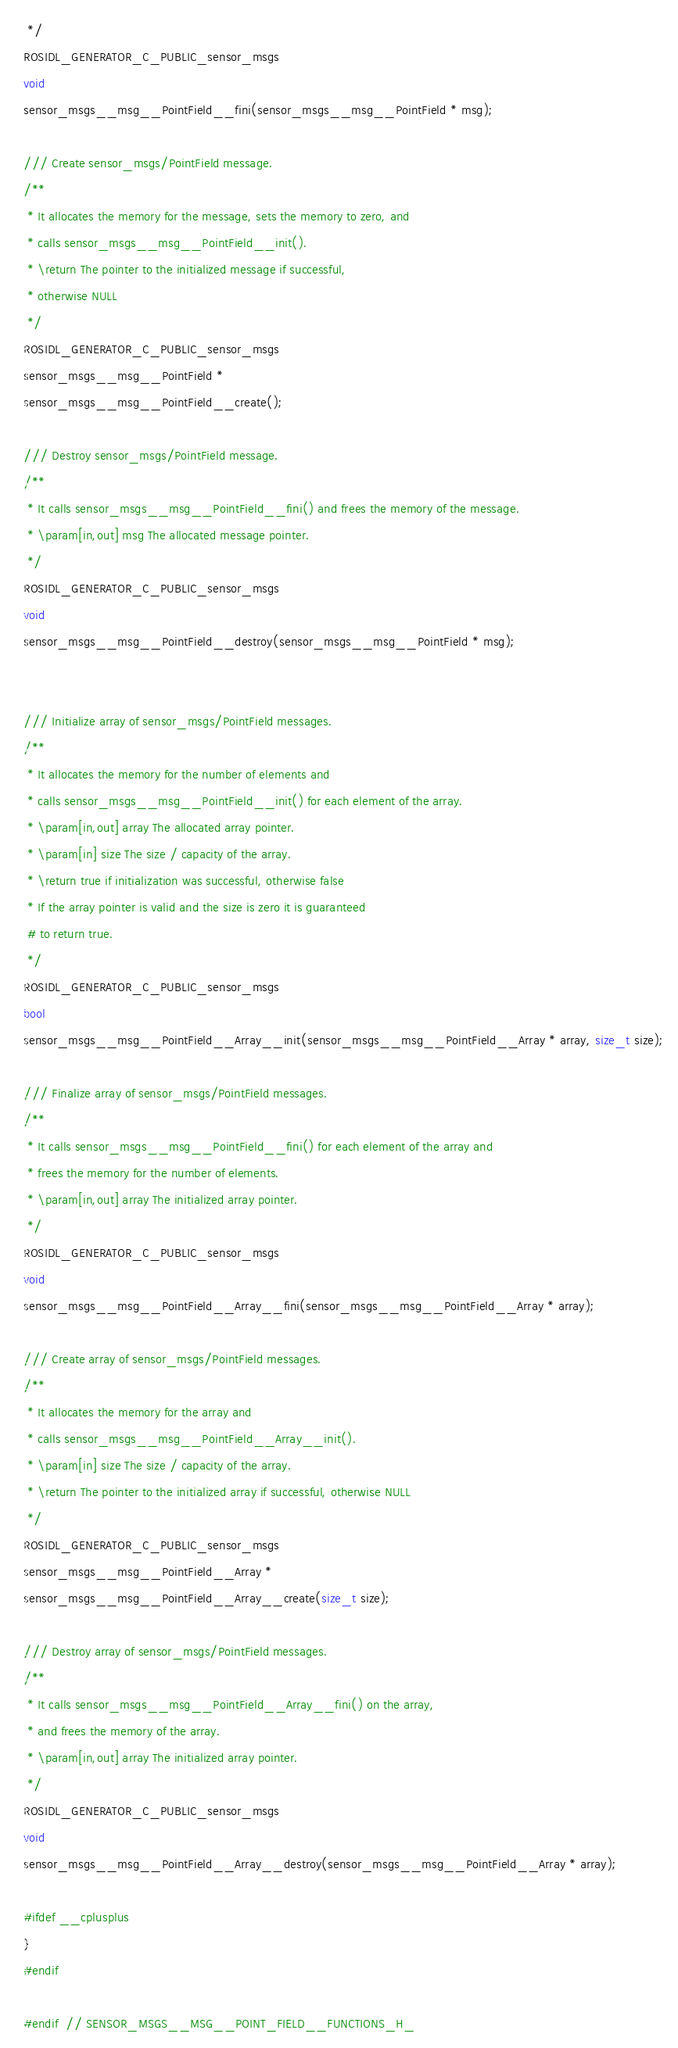Convert code to text. <code><loc_0><loc_0><loc_500><loc_500><_C_> */
ROSIDL_GENERATOR_C_PUBLIC_sensor_msgs
void
sensor_msgs__msg__PointField__fini(sensor_msgs__msg__PointField * msg);

/// Create sensor_msgs/PointField message.
/**
 * It allocates the memory for the message, sets the memory to zero, and
 * calls sensor_msgs__msg__PointField__init().
 * \return The pointer to the initialized message if successful,
 * otherwise NULL
 */
ROSIDL_GENERATOR_C_PUBLIC_sensor_msgs
sensor_msgs__msg__PointField *
sensor_msgs__msg__PointField__create();

/// Destroy sensor_msgs/PointField message.
/**
 * It calls sensor_msgs__msg__PointField__fini() and frees the memory of the message.
 * \param[in,out] msg The allocated message pointer.
 */
ROSIDL_GENERATOR_C_PUBLIC_sensor_msgs
void
sensor_msgs__msg__PointField__destroy(sensor_msgs__msg__PointField * msg);


/// Initialize array of sensor_msgs/PointField messages.
/**
 * It allocates the memory for the number of elements and
 * calls sensor_msgs__msg__PointField__init() for each element of the array.
 * \param[in,out] array The allocated array pointer.
 * \param[in] size The size / capacity of the array.
 * \return true if initialization was successful, otherwise false
 * If the array pointer is valid and the size is zero it is guaranteed
 # to return true.
 */
ROSIDL_GENERATOR_C_PUBLIC_sensor_msgs
bool
sensor_msgs__msg__PointField__Array__init(sensor_msgs__msg__PointField__Array * array, size_t size);

/// Finalize array of sensor_msgs/PointField messages.
/**
 * It calls sensor_msgs__msg__PointField__fini() for each element of the array and
 * frees the memory for the number of elements.
 * \param[in,out] array The initialized array pointer.
 */
ROSIDL_GENERATOR_C_PUBLIC_sensor_msgs
void
sensor_msgs__msg__PointField__Array__fini(sensor_msgs__msg__PointField__Array * array);

/// Create array of sensor_msgs/PointField messages.
/**
 * It allocates the memory for the array and
 * calls sensor_msgs__msg__PointField__Array__init().
 * \param[in] size The size / capacity of the array.
 * \return The pointer to the initialized array if successful, otherwise NULL
 */
ROSIDL_GENERATOR_C_PUBLIC_sensor_msgs
sensor_msgs__msg__PointField__Array *
sensor_msgs__msg__PointField__Array__create(size_t size);

/// Destroy array of sensor_msgs/PointField messages.
/**
 * It calls sensor_msgs__msg__PointField__Array__fini() on the array,
 * and frees the memory of the array.
 * \param[in,out] array The initialized array pointer.
 */
ROSIDL_GENERATOR_C_PUBLIC_sensor_msgs
void
sensor_msgs__msg__PointField__Array__destroy(sensor_msgs__msg__PointField__Array * array);

#ifdef __cplusplus
}
#endif

#endif  // SENSOR_MSGS__MSG__POINT_FIELD__FUNCTIONS_H_
</code> 